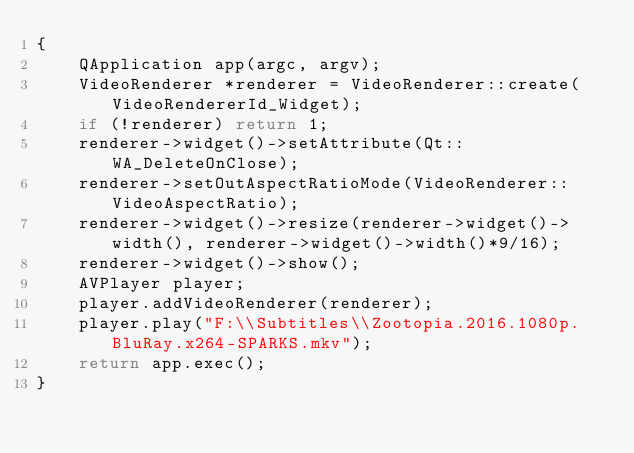Convert code to text. <code><loc_0><loc_0><loc_500><loc_500><_C++_>{
    QApplication app(argc, argv);
	VideoRenderer *renderer = VideoRenderer::create(VideoRendererId_Widget);
    if (!renderer) return 1;
    renderer->widget()->setAttribute(Qt::WA_DeleteOnClose);
    renderer->setOutAspectRatioMode(VideoRenderer::VideoAspectRatio);
    renderer->widget()->resize(renderer->widget()->width(), renderer->widget()->width()*9/16);
    renderer->widget()->show();
    AVPlayer player;
    player.addVideoRenderer(renderer);
    player.play("F:\\Subtitles\\Zootopia.2016.1080p.BluRay.x264-SPARKS.mkv");
    return app.exec();
}
</code> 